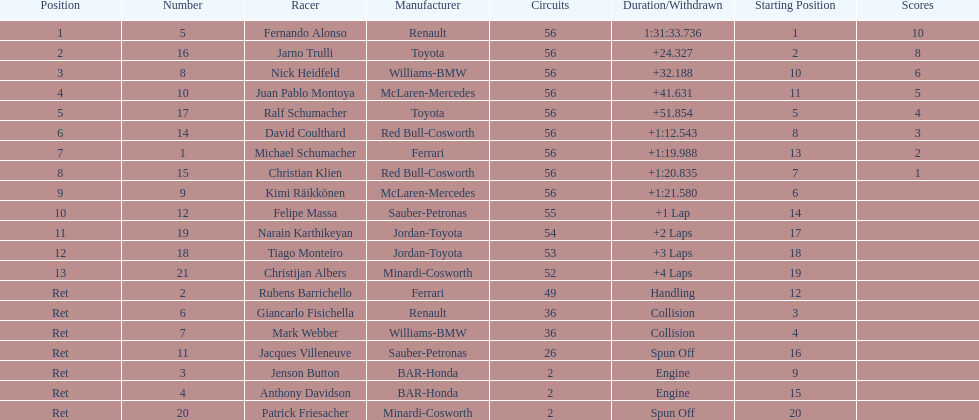Who finished before nick heidfeld? Jarno Trulli. 